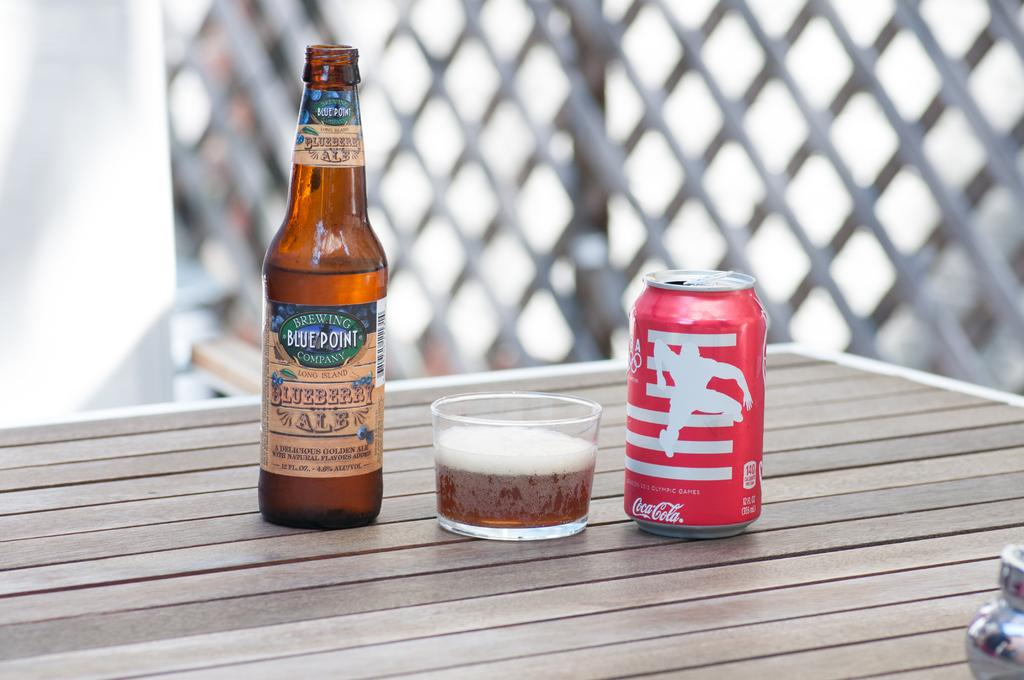<image>
Write a terse but informative summary of the picture. A bottle of Bluepoint Blueberry Ale stands on a table alongside a small glass and a can of soda. 